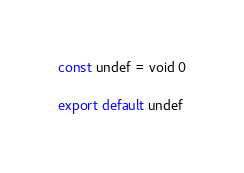<code> <loc_0><loc_0><loc_500><loc_500><_JavaScript_>const undef = void 0

export default undef
</code> 